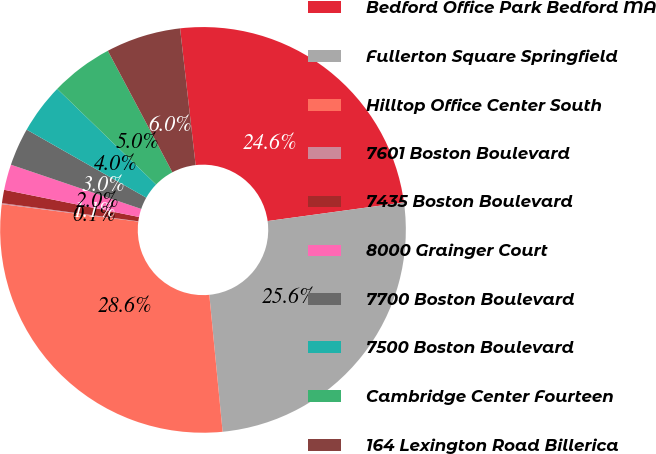Convert chart to OTSL. <chart><loc_0><loc_0><loc_500><loc_500><pie_chart><fcel>Bedford Office Park Bedford MA<fcel>Fullerton Square Springfield<fcel>Hilltop Office Center South<fcel>7601 Boston Boulevard<fcel>7435 Boston Boulevard<fcel>8000 Grainger Court<fcel>7700 Boston Boulevard<fcel>7500 Boston Boulevard<fcel>Cambridge Center Fourteen<fcel>164 Lexington Road Billerica<nl><fcel>24.64%<fcel>25.62%<fcel>28.57%<fcel>0.08%<fcel>1.06%<fcel>2.04%<fcel>3.02%<fcel>4.01%<fcel>4.99%<fcel>5.97%<nl></chart> 